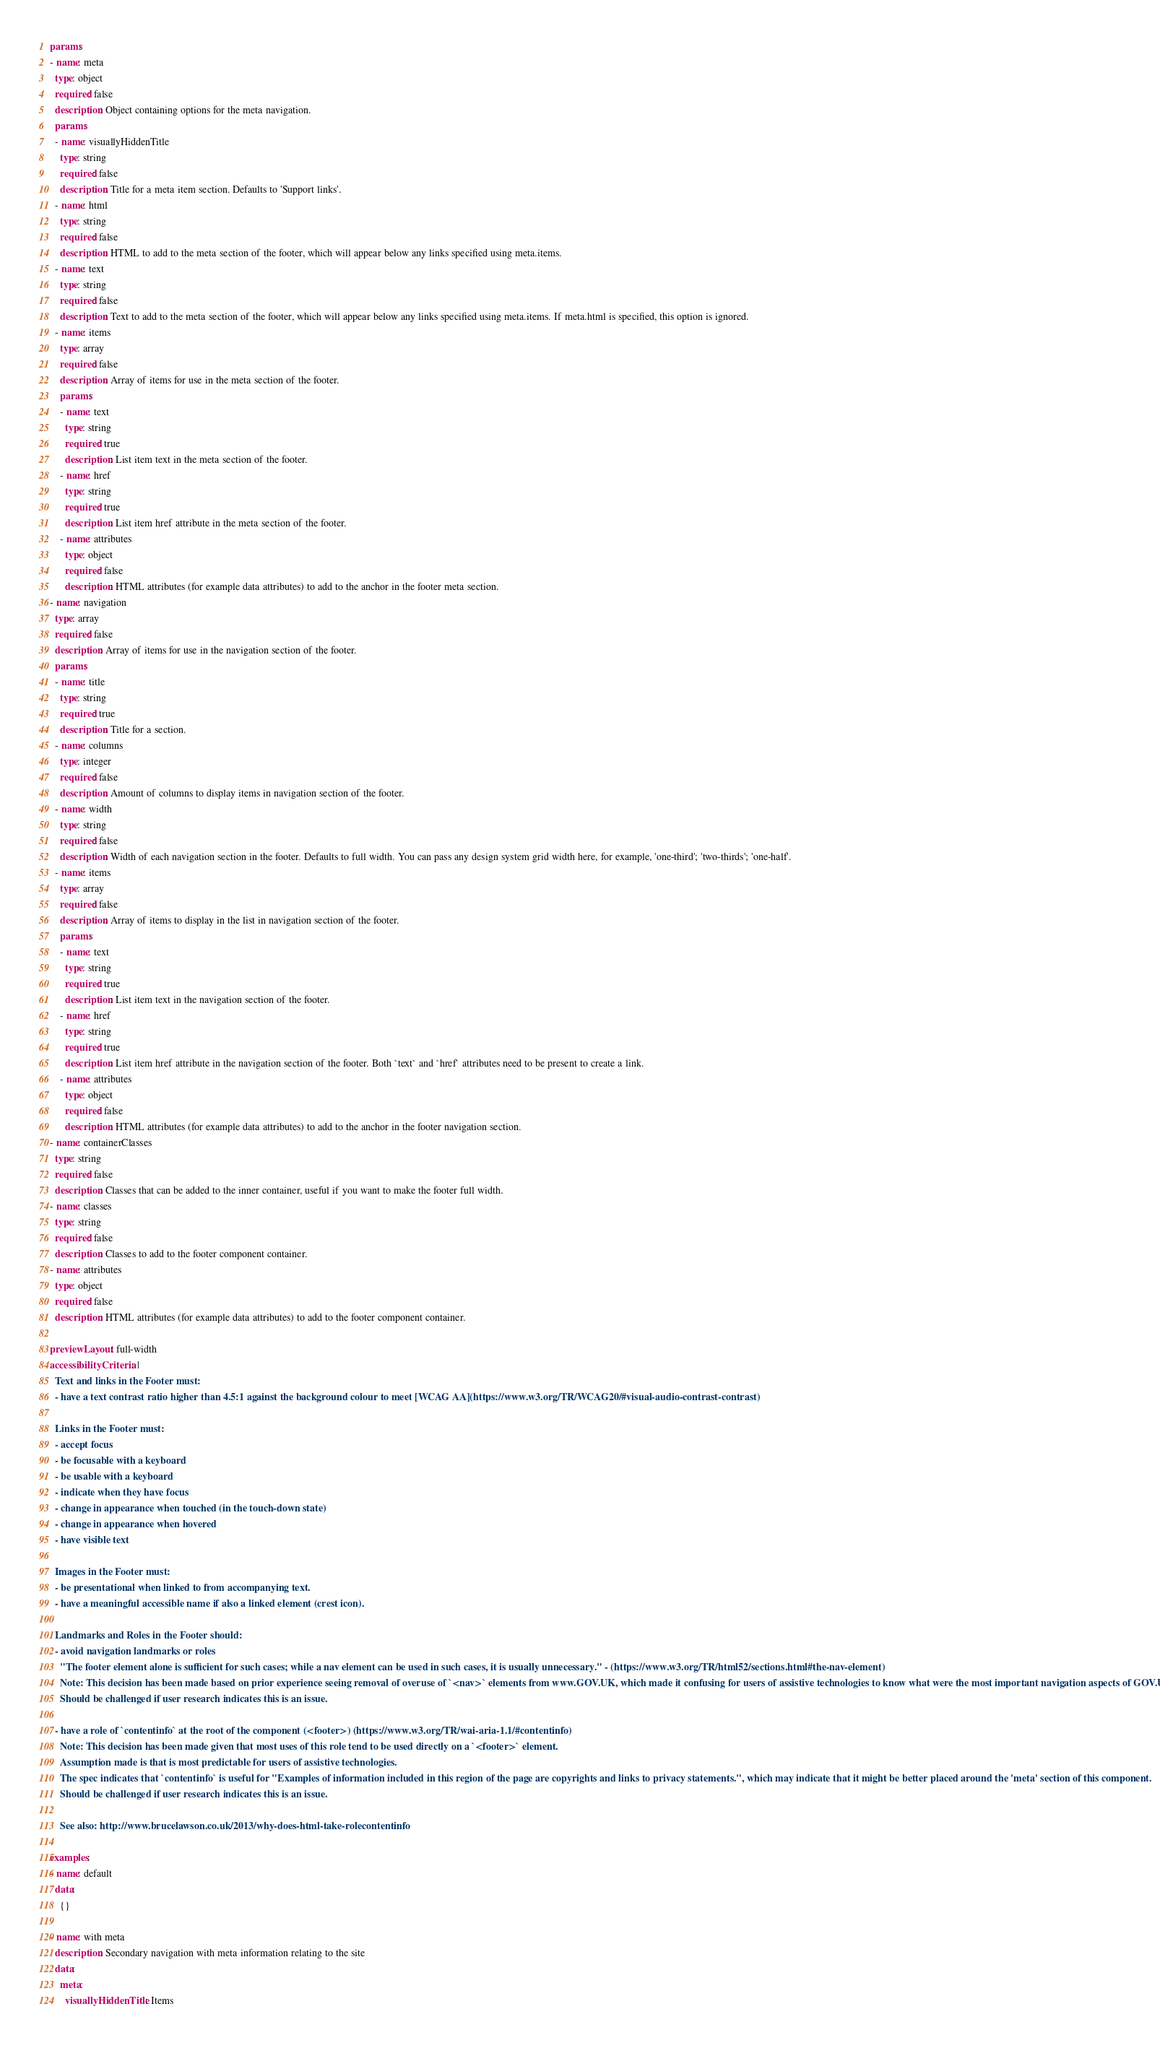Convert code to text. <code><loc_0><loc_0><loc_500><loc_500><_YAML_>params:
- name: meta
  type: object
  required: false
  description: Object containing options for the meta navigation.
  params:
  - name: visuallyHiddenTitle
    type: string
    required: false
    description: Title for a meta item section. Defaults to 'Support links'.
  - name: html
    type: string
    required: false
    description: HTML to add to the meta section of the footer, which will appear below any links specified using meta.items.
  - name: text
    type: string
    required: false
    description: Text to add to the meta section of the footer, which will appear below any links specified using meta.items. If meta.html is specified, this option is ignored.
  - name: items
    type: array
    required: false
    description: Array of items for use in the meta section of the footer.
    params:
    - name: text
      type: string
      required: true
      description: List item text in the meta section of the footer.
    - name: href
      type: string
      required: true
      description: List item href attribute in the meta section of the footer.
    - name: attributes
      type: object
      required: false
      description: HTML attributes (for example data attributes) to add to the anchor in the footer meta section.
- name: navigation
  type: array
  required: false
  description: Array of items for use in the navigation section of the footer.
  params:
  - name: title
    type: string
    required: true
    description: Title for a section.
  - name: columns
    type: integer
    required: false
    description: Amount of columns to display items in navigation section of the footer.
  - name: width
    type: string
    required: false
    description: Width of each navigation section in the footer. Defaults to full width. You can pass any design system grid width here, for example, 'one-third'; 'two-thirds'; 'one-half'.
  - name: items
    type: array
    required: false
    description: Array of items to display in the list in navigation section of the footer.
    params:
    - name: text
      type: string
      required: true
      description: List item text in the navigation section of the footer.
    - name: href
      type: string
      required: true
      description: List item href attribute in the navigation section of the footer. Both `text` and `href` attributes need to be present to create a link.
    - name: attributes
      type: object
      required: false
      description: HTML attributes (for example data attributes) to add to the anchor in the footer navigation section.
- name: containerClasses
  type: string
  required: false
  description: Classes that can be added to the inner container, useful if you want to make the footer full width.
- name: classes
  type: string
  required: false
  description: Classes to add to the footer component container.
- name: attributes
  type: object
  required: false
  description: HTML attributes (for example data attributes) to add to the footer component container.

previewLayout: full-width
accessibilityCriteria: |
  Text and links in the Footer must:
  - have a text contrast ratio higher than 4.5:1 against the background colour to meet [WCAG AA](https://www.w3.org/TR/WCAG20/#visual-audio-contrast-contrast)

  Links in the Footer must:
  - accept focus
  - be focusable with a keyboard
  - be usable with a keyboard
  - indicate when they have focus
  - change in appearance when touched (in the touch-down state)
  - change in appearance when hovered
  - have visible text

  Images in the Footer must:
  - be presentational when linked to from accompanying text.
  - have a meaningful accessible name if also a linked element (crest icon).

  Landmarks and Roles in the Footer should:
  - avoid navigation landmarks or roles
    "The footer element alone is sufficient for such cases; while a nav element can be used in such cases, it is usually unnecessary." - (https://www.w3.org/TR/html52/sections.html#the-nav-element)
    Note: This decision has been made based on prior experience seeing removal of overuse of `<nav>` elements from www.GOV.UK, which made it confusing for users of assistive technologies to know what were the most important navigation aspects of GOV.UK.
    Should be challenged if user research indicates this is an issue.

  - have a role of `contentinfo` at the root of the component (<footer>) (https://www.w3.org/TR/wai-aria-1.1/#contentinfo)
    Note: This decision has been made given that most uses of this role tend to be used directly on a `<footer>` element.
    Assumption made is that is most predictable for users of assistive technologies.
    The spec indicates that `contentinfo` is useful for "Examples of information included in this region of the page are copyrights and links to privacy statements.", which may indicate that it might be better placed around the 'meta' section of this component.
    Should be challenged if user research indicates this is an issue.

    See also: http://www.brucelawson.co.uk/2013/why-does-html-take-rolecontentinfo

examples:
- name: default
  data:
    {}

- name: with meta
  description: Secondary navigation with meta information relating to the site
  data:
    meta:
      visuallyHiddenTitle: Items</code> 